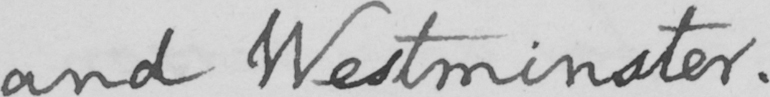Please provide the text content of this handwritten line. and Westminster . 